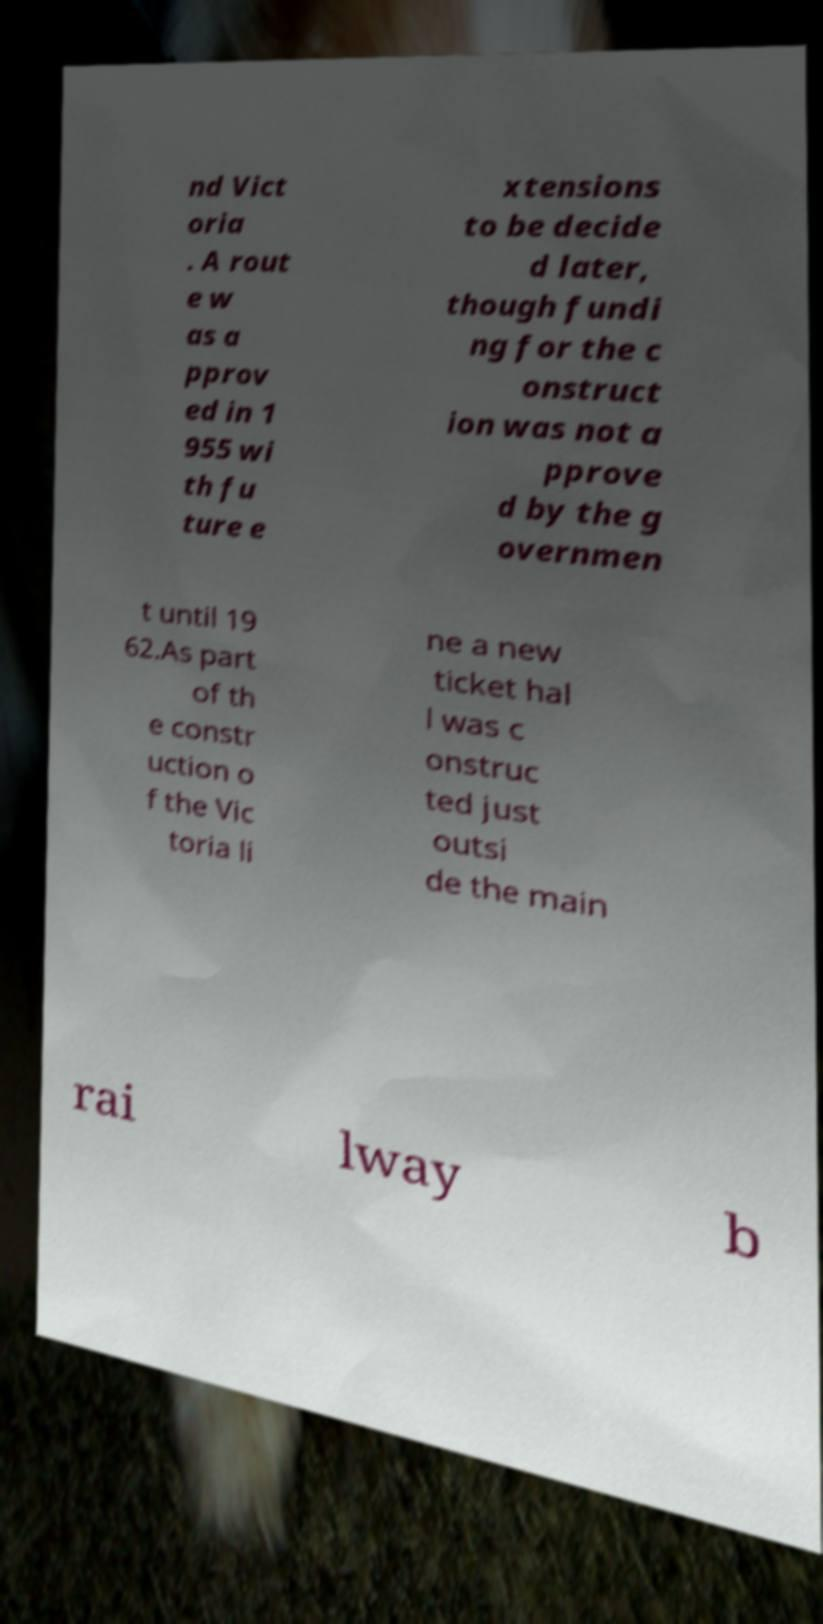Can you read and provide the text displayed in the image?This photo seems to have some interesting text. Can you extract and type it out for me? nd Vict oria . A rout e w as a pprov ed in 1 955 wi th fu ture e xtensions to be decide d later, though fundi ng for the c onstruct ion was not a pprove d by the g overnmen t until 19 62.As part of th e constr uction o f the Vic toria li ne a new ticket hal l was c onstruc ted just outsi de the main rai lway b 